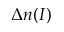Convert formula to latex. <formula><loc_0><loc_0><loc_500><loc_500>\Delta n ( I )</formula> 